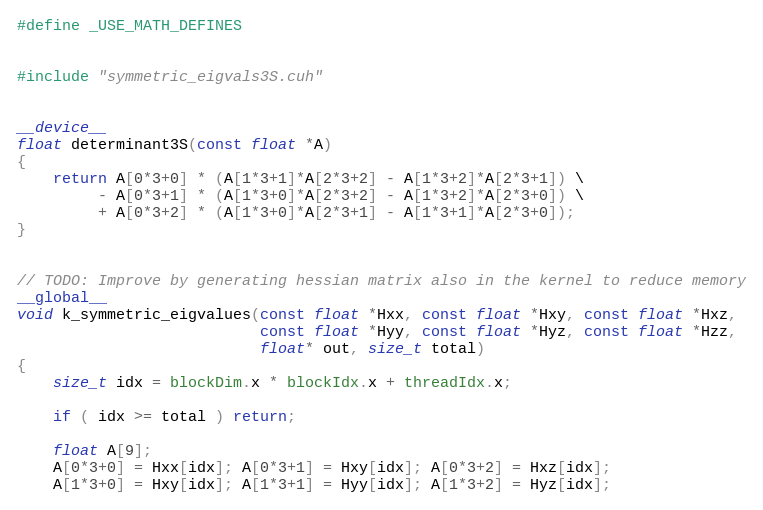Convert code to text. <code><loc_0><loc_0><loc_500><loc_500><_Cuda_>#define _USE_MATH_DEFINES


#include "symmetric_eigvals3S.cuh"


__device__
float determinant3S(const float *A)
{
    return A[0*3+0] * (A[1*3+1]*A[2*3+2] - A[1*3+2]*A[2*3+1]) \
         - A[0*3+1] * (A[1*3+0]*A[2*3+2] - A[1*3+2]*A[2*3+0]) \
         + A[0*3+2] * (A[1*3+0]*A[2*3+1] - A[1*3+1]*A[2*3+0]);
}


// TODO: Improve by generating hessian matrix also in the kernel to reduce memory
__global__
void k_symmetric_eigvalues(const float *Hxx, const float *Hxy, const float *Hxz,
                           const float *Hyy, const float *Hyz, const float *Hzz,
                           float* out, size_t total)
{
    size_t idx = blockDim.x * blockIdx.x + threadIdx.x;

    if ( idx >= total ) return;

    float A[9];
    A[0*3+0] = Hxx[idx]; A[0*3+1] = Hxy[idx]; A[0*3+2] = Hxz[idx];
    A[1*3+0] = Hxy[idx]; A[1*3+1] = Hyy[idx]; A[1*3+2] = Hyz[idx];</code> 